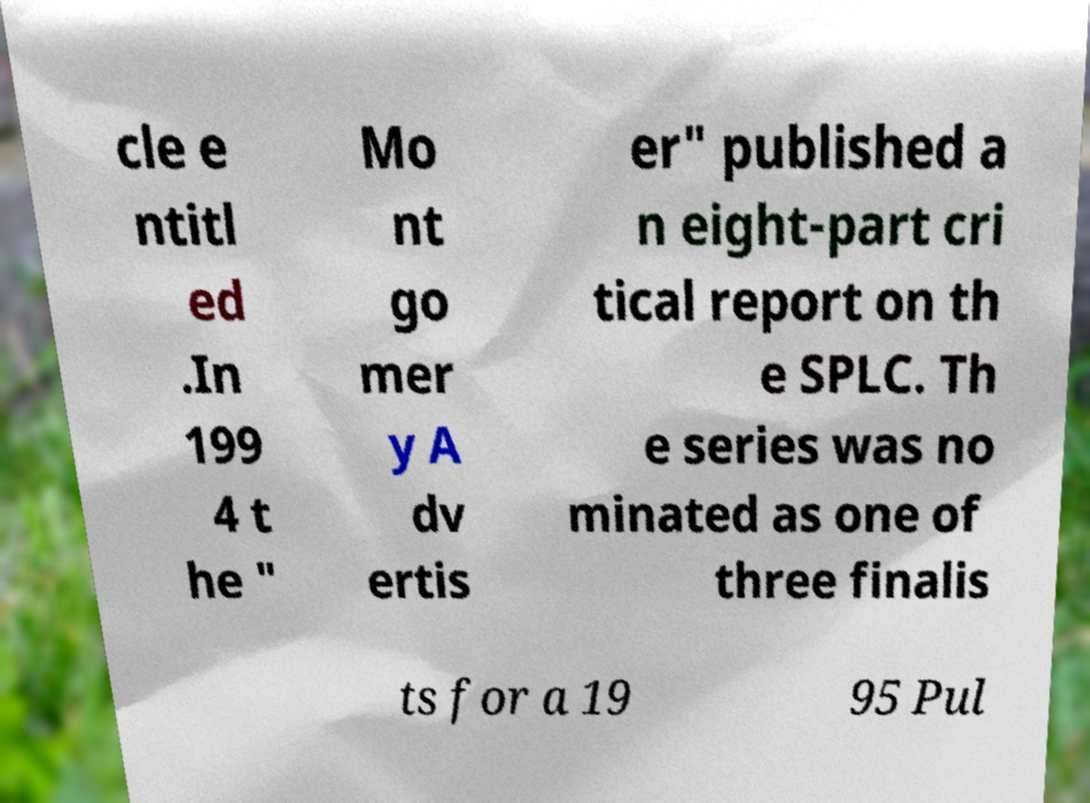I need the written content from this picture converted into text. Can you do that? cle e ntitl ed .In 199 4 t he " Mo nt go mer y A dv ertis er" published a n eight-part cri tical report on th e SPLC. Th e series was no minated as one of three finalis ts for a 19 95 Pul 